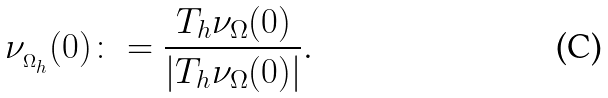Convert formula to latex. <formula><loc_0><loc_0><loc_500><loc_500>\nu _ { _ { \Omega _ { h } } } ( 0 ) \colon = \frac { T _ { h } \nu _ { \Omega } ( 0 ) } { | T _ { h } \nu _ { \Omega } ( 0 ) | } .</formula> 